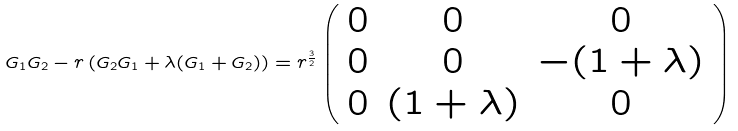Convert formula to latex. <formula><loc_0><loc_0><loc_500><loc_500>G _ { 1 } G _ { 2 } - r \left ( G _ { 2 } G _ { 1 } + \lambda ( G _ { 1 } + G _ { 2 } ) \right ) = r ^ { \frac { 3 } { 2 } } \left ( \begin{array} { c c c } 0 & 0 & 0 \\ 0 & 0 & - ( 1 + \lambda ) \\ 0 & ( 1 + \lambda ) & 0 \end{array} \right )</formula> 